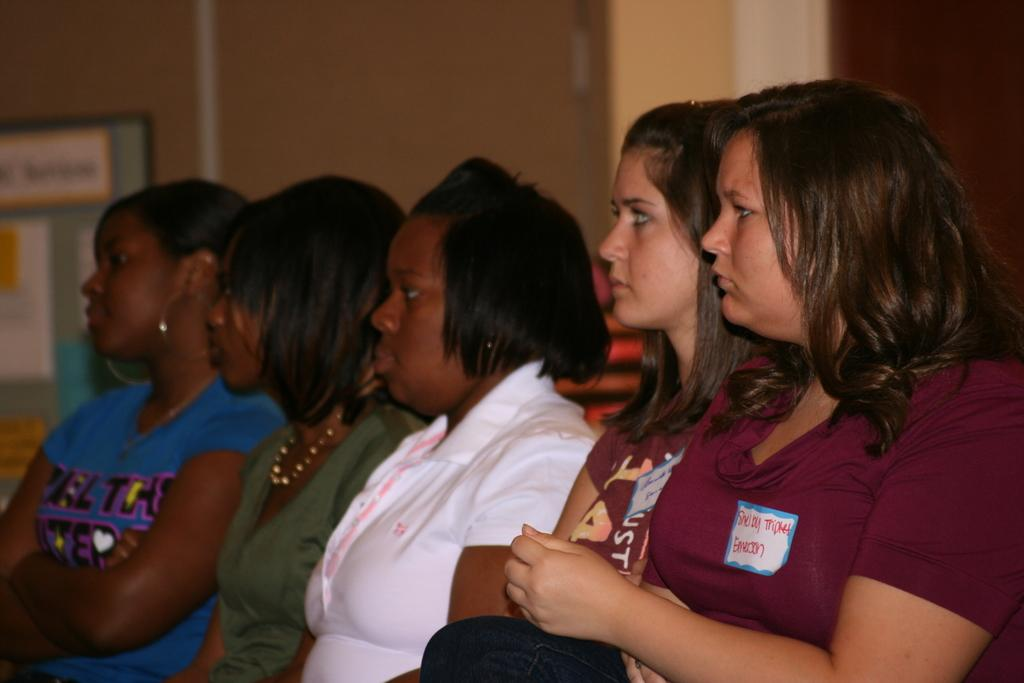What are the people in the image doing? The people in the image are sitting in the center. What are the people wearing? The people are wearing different colored t-shirts. What can be seen in the background of the image? There is a wall and a banner in the background, as well as other objects. What type of discussion is taking place between the squirrels in the image? There are no squirrels present in the image, so no discussion can be observed. 